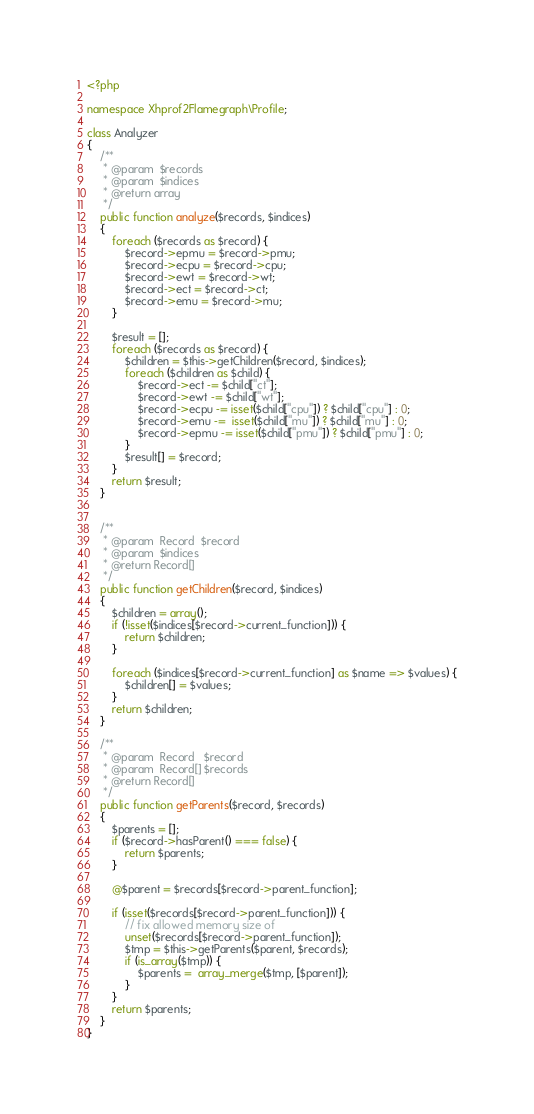Convert code to text. <code><loc_0><loc_0><loc_500><loc_500><_PHP_><?php

namespace Xhprof2Flamegraph\Profile;

class Analyzer
{
    /**
     * @param  $records
     * @param  $indices
     * @return array
     */
    public function analyze($records, $indices)
    {
        foreach ($records as $record) {
            $record->epmu = $record->pmu;
            $record->ecpu = $record->cpu;
            $record->ewt = $record->wt;
            $record->ect = $record->ct;
            $record->emu = $record->mu;
        }

        $result = [];
        foreach ($records as $record) {
            $children = $this->getChildren($record, $indices);
            foreach ($children as $child) {
                $record->ect -= $child["ct"];
                $record->ewt -= $child["wt"];
                $record->ecpu -= isset($child["cpu"]) ? $child["cpu"] : 0;
                $record->emu -=  isset($child["mu"]) ? $child["mu"] : 0;
                $record->epmu -= isset($child["pmu"]) ? $child["pmu"] : 0;
            }
            $result[] = $record;
        }
        return $result;
    }


    /**
     * @param  Record  $record
     * @param  $indices
     * @return Record[]
     */
    public function getChildren($record, $indices)
    {
        $children = array();
        if (!isset($indices[$record->current_function])) {
            return $children;
        }

        foreach ($indices[$record->current_function] as $name => $values) {
            $children[] = $values;
        }
        return $children;
    }

    /**
     * @param  Record   $record
     * @param  Record[] $records
     * @return Record[]
     */
    public function getParents($record, $records)
    {
        $parents = [];
        if ($record->hasParent() === false) {
            return $parents;
        }

        @$parent = $records[$record->parent_function];

        if (isset($records[$record->parent_function])) {
            // fix allowed memory size of
            unset($records[$record->parent_function]);
            $tmp = $this->getParents($parent, $records);
            if (is_array($tmp)) {
                $parents =  array_merge($tmp, [$parent]);
            }
        }
        return $parents;
    }
}
</code> 